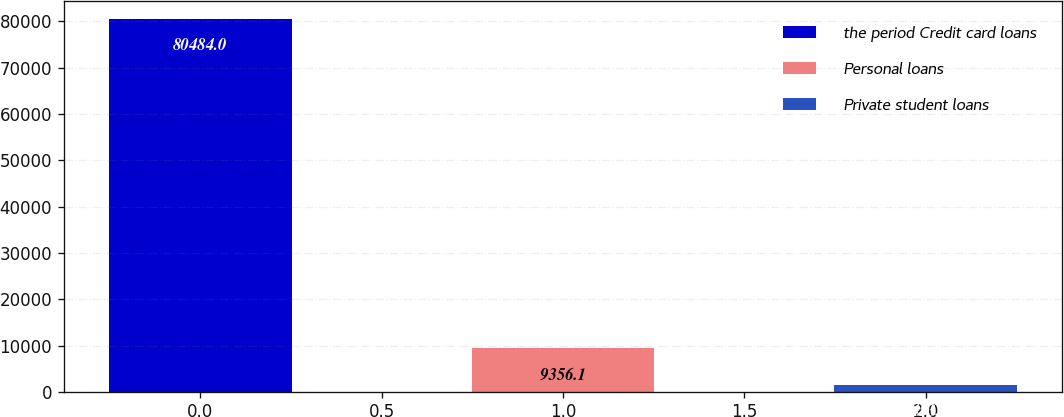Convert chart to OTSL. <chart><loc_0><loc_0><loc_500><loc_500><bar_chart><fcel>the period Credit card loans<fcel>Personal loans<fcel>Private student loans<nl><fcel>80484<fcel>9356.1<fcel>1453<nl></chart> 